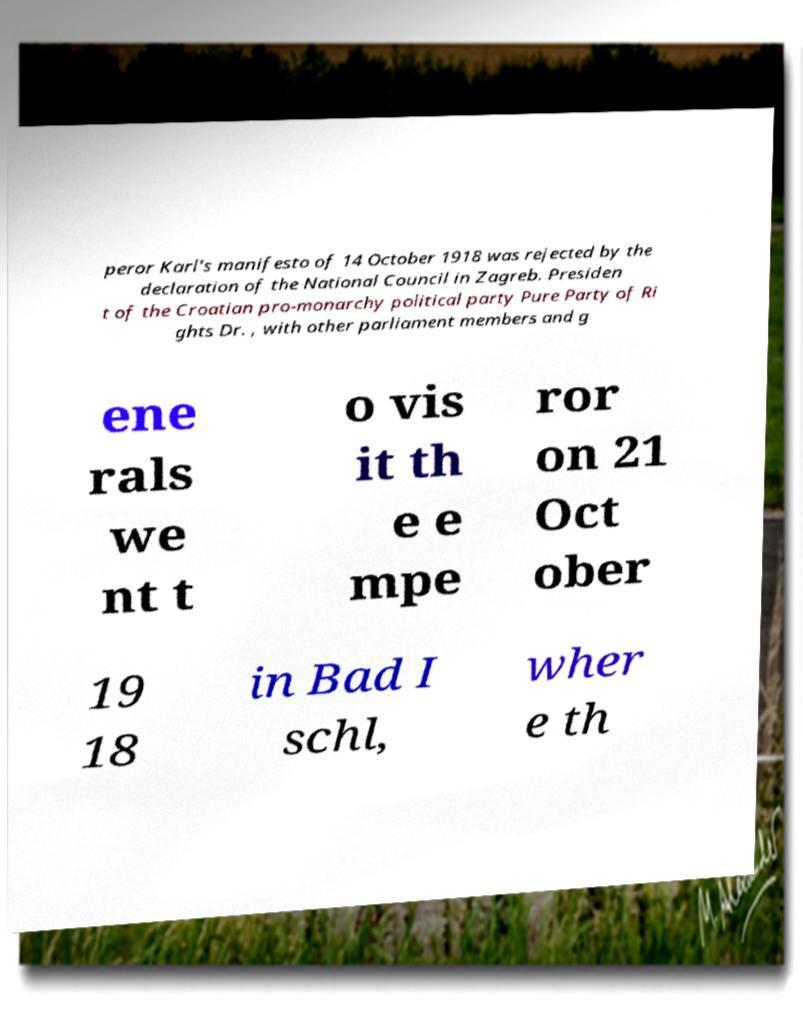Can you read and provide the text displayed in the image?This photo seems to have some interesting text. Can you extract and type it out for me? peror Karl's manifesto of 14 October 1918 was rejected by the declaration of the National Council in Zagreb. Presiden t of the Croatian pro-monarchy political party Pure Party of Ri ghts Dr. , with other parliament members and g ene rals we nt t o vis it th e e mpe ror on 21 Oct ober 19 18 in Bad I schl, wher e th 